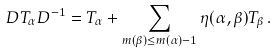<formula> <loc_0><loc_0><loc_500><loc_500>D T _ { \alpha } D ^ { - 1 } = T _ { \alpha } + \sum _ { m ( \beta ) \leq m ( \alpha ) - 1 } \eta ( \alpha , \beta ) T _ { \beta } \, .</formula> 